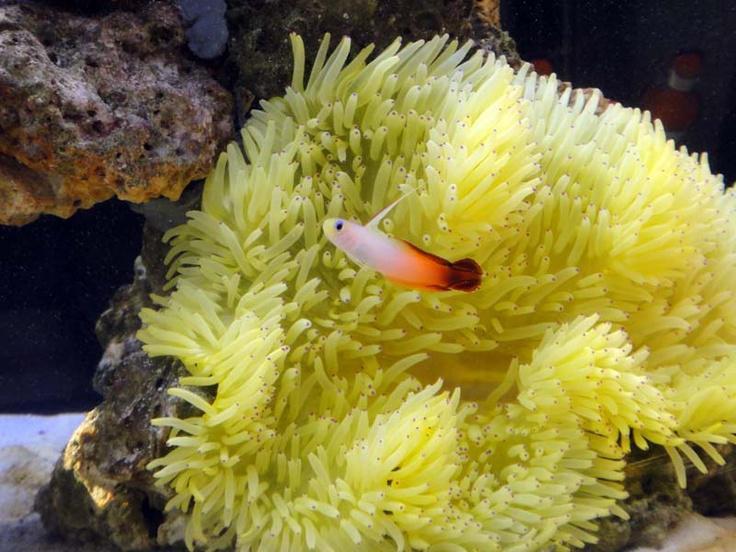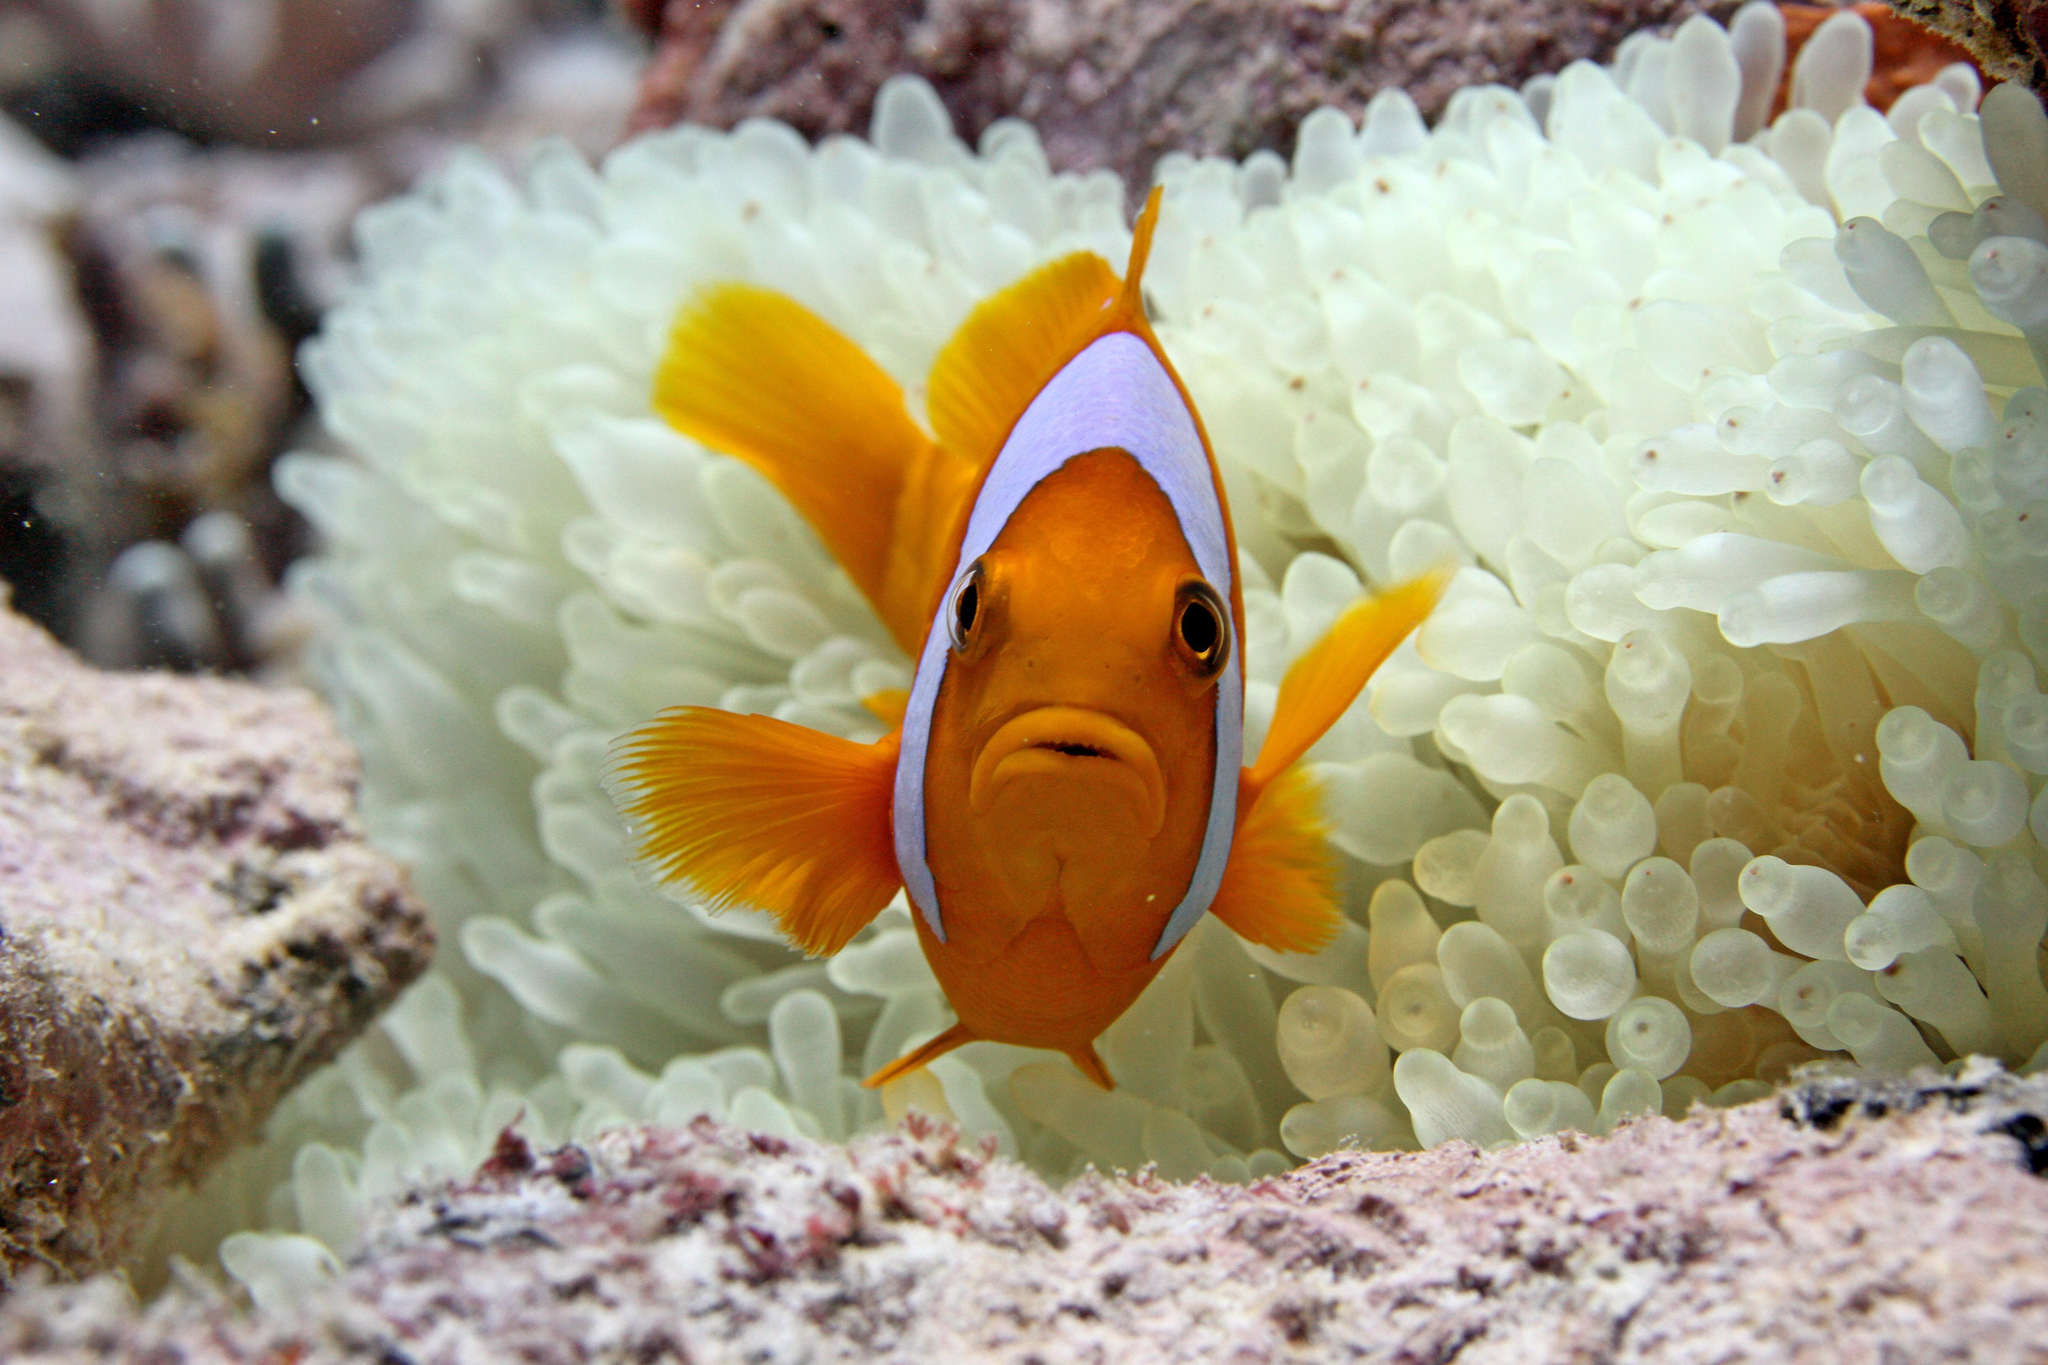The first image is the image on the left, the second image is the image on the right. Given the left and right images, does the statement "The only living thing in one of the images is an anemone." hold true? Answer yes or no. No. The first image is the image on the left, the second image is the image on the right. Assess this claim about the two images: "At least one image shows a bright yellow anemone with tendrils that have a black dot on the end.". Correct or not? Answer yes or no. Yes. 